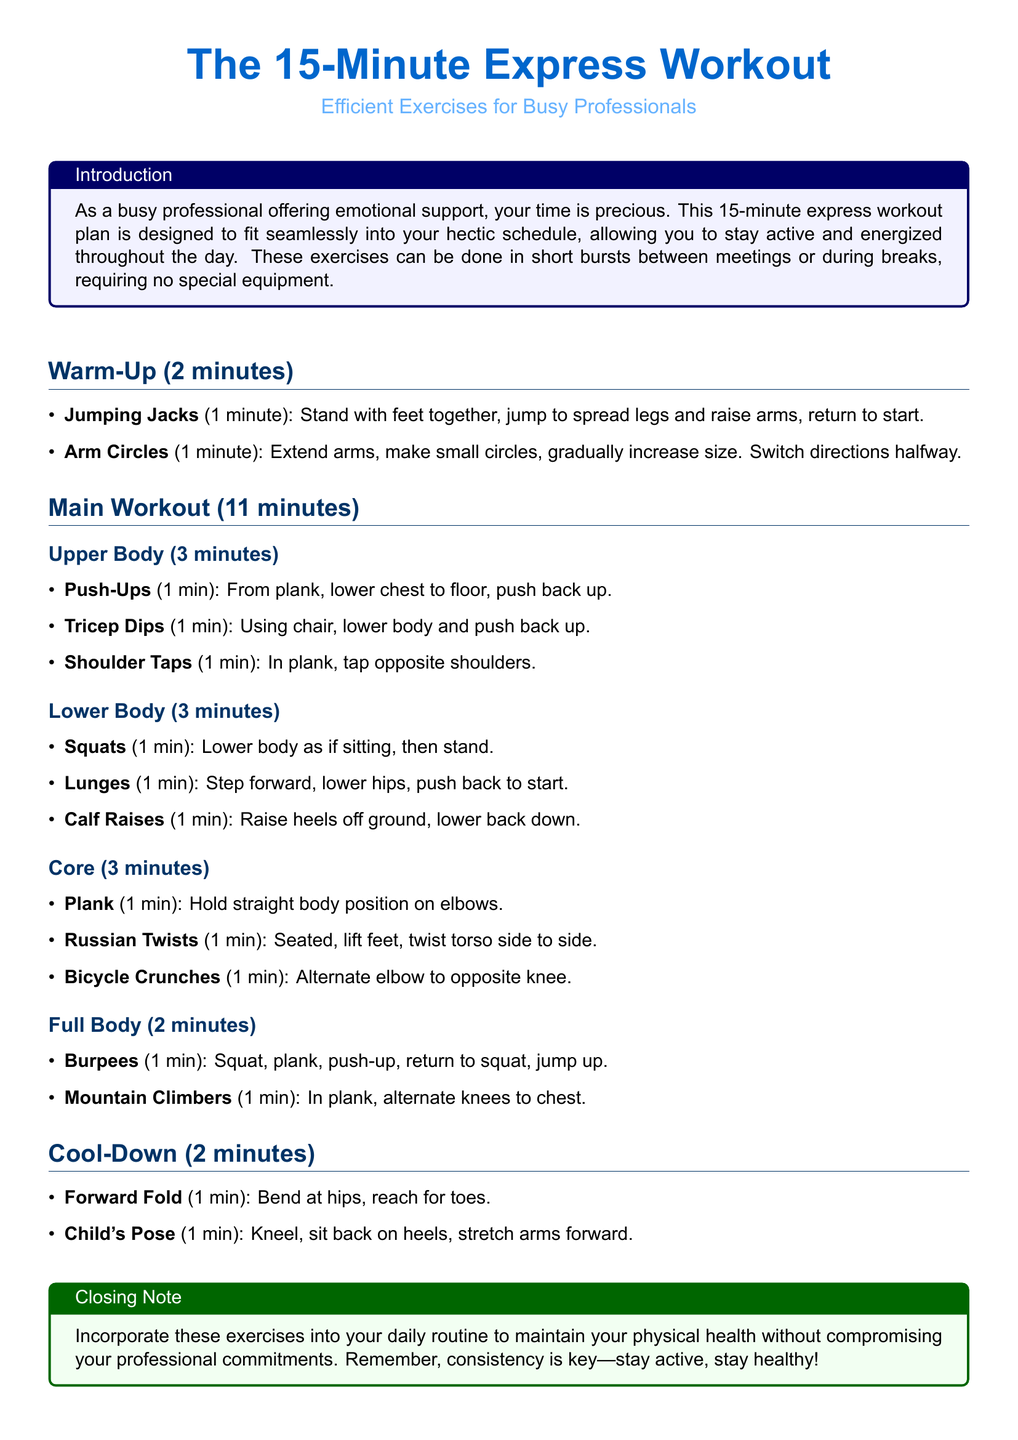what is the total duration of the workout? The workout duration includes warm-up, main workout, and cool-down sections, totaling 15 minutes.
Answer: 15 minutes how long is the cool-down section? The cool-down section consists of two exercises totaling 2 minutes as specified in the document.
Answer: 2 minutes what type of workout is provided in this document? The document outlines an express workout plan designed specifically for busy professionals requiring short bursts of exercises.
Answer: express workout what exercise is performed for the upper body? The exercises for the upper body include push-ups, tricep dips, and shoulder taps listed in the main workout section.
Answer: push-ups, tricep dips, shoulder taps how many minutes are dedicated to the core workouts? The core workout section lists three exercises, each performed for one minute, leading to a total of 3 minutes for this segment.
Answer: 3 minutes which exercise requires a chair? The document specifies tricep dips as the exercise that utilizes a chair.
Answer: tricep dips how many exercises are listed in the main workout? The main workout section includes a total of 11 distinct exercises divided across upper body, lower body, core, and full body segments.
Answer: 11 exercises what is the first exercise in the warm-up? The first exercise in the warm-up is jumping jacks, performed for one minute.
Answer: jumping jacks 